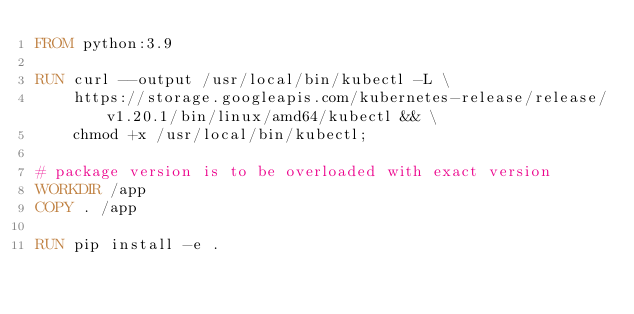<code> <loc_0><loc_0><loc_500><loc_500><_Dockerfile_>FROM python:3.9

RUN curl --output /usr/local/bin/kubectl -L \
    https://storage.googleapis.com/kubernetes-release/release/v1.20.1/bin/linux/amd64/kubectl && \
    chmod +x /usr/local/bin/kubectl;

# package version is to be overloaded with exact version
WORKDIR /app
COPY . /app

RUN pip install -e .
</code> 